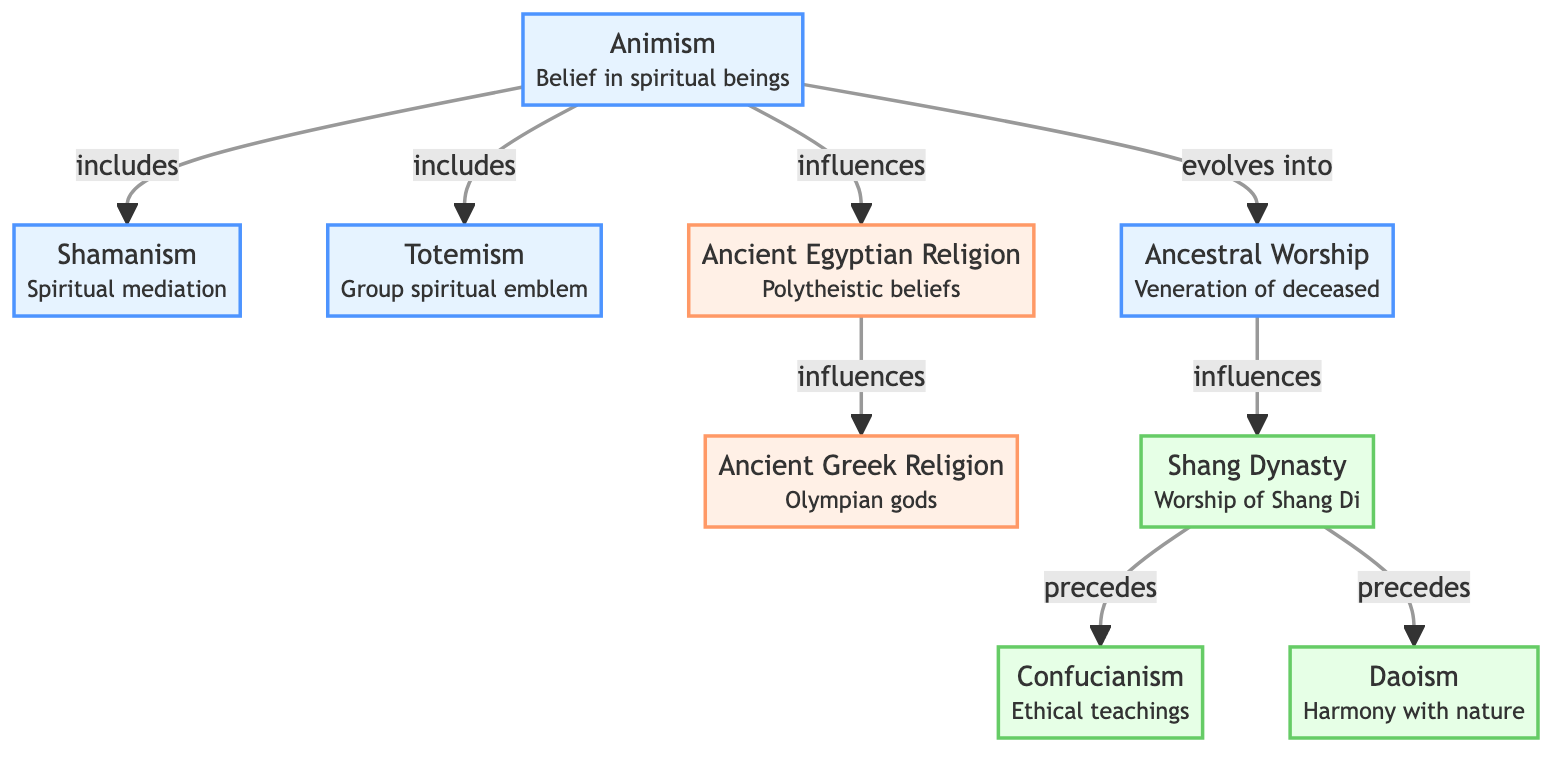What are the three indigenous beliefs listed in the diagram? The diagram showcases three indigenous beliefs: Animism, Shamanism, and Totemism. These beliefs are visually presented at the top of the diagram under the indigenous category.
Answer: Animism, Shamanism, Totemism Which belief evolves into Ancestor Worship? The diagram indicates that Animism evolves into Ancestor Worship, as represented by the directed arrow from Animism to Ancestors.
Answer: Animism How many relationships influence the Ancient Egyptian Religion? The diagram illustrates two relationships leading to the Ancient Egyptian Religion: one from Animism and another from Egyptian Religion itself influencing Hellenism. Therefore, there are two influencing relationships.
Answer: 2 Which belief precedes Confucianism? The diagram shows that ShangDi precedes Confucianism as indicated by the directed arrow from ShangDi to Confucianism.
Answer: ShangDi What type of relationship exists between Ancestor Worship and ShangDi? The diagram shows that Ancestor Worship influences ShangDi, indicated by the directional arrow from Ancestors to ShangDi, highlighting a cause-and-effect relationship.
Answer: influences Which organized religious belief was influenced by the Ancient Egyptian Religion? According to the diagram, the organized religious belief influenced by Ancient Egyptian Religion is Hellenism, as depicted by the relationship shown between these two nodes.
Answer: Hellenism What do Daoism and Confucianism share in terms of their relationship to ShangDi? Both Daoism and Confucianism share that they are both preceded by ShangDi in the diagram. This indicates a chronological flow in the development of these belief systems.
Answer: preceded How many total nodes are present in the diagram? The diagram contains a total of 10 nodes: Animism, Shamanism, Totemism, Ancestor Worship, Ancient Egyptian Religion, Hellenism, ShangDi, Confucianism, and Daoism. By adding these together, we find there are 10 nodes.
Answer: 10 Which indigenous belief includes both Shamanism and Totemism? The diagram shows that Animism includes both Shamanism and Totemism, as indicated by the arrows pointing from Animism to these two beliefs.
Answer: Animism What is the primary cultural emphasis of Confucianism as represented in the diagram? The diagram represents Confucianism as an ethical teaching, signifying its focus on moral principles and societal values.
Answer: Ethical teachings 